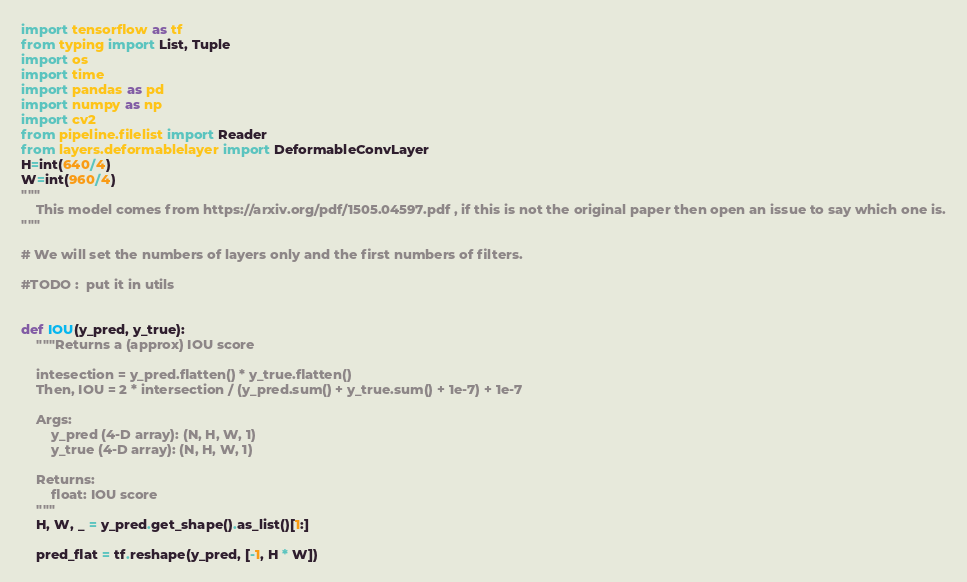Convert code to text. <code><loc_0><loc_0><loc_500><loc_500><_Python_>import tensorflow as tf 
from typing import List, Tuple
import os
import time
import pandas as pd
import numpy as np
import cv2
from pipeline.filelist import Reader
from layers.deformablelayer import DeformableConvLayer
H=int(640/4)
W=int(960/4)
"""
    This model comes from https://arxiv.org/pdf/1505.04597.pdf , if this is not the original paper then open an issue to say which one is.
"""

# We will set the numbers of layers only and the first numbers of filters.

#TODO :  put it in utils


def IOU(y_pred, y_true):
    """Returns a (approx) IOU score

    intesection = y_pred.flatten() * y_true.flatten()
    Then, IOU = 2 * intersection / (y_pred.sum() + y_true.sum() + 1e-7) + 1e-7

    Args:
        y_pred (4-D array): (N, H, W, 1)
        y_true (4-D array): (N, H, W, 1)

    Returns:
        float: IOU score
    """
    H, W, _ = y_pred.get_shape().as_list()[1:]

    pred_flat = tf.reshape(y_pred, [-1, H * W])</code> 